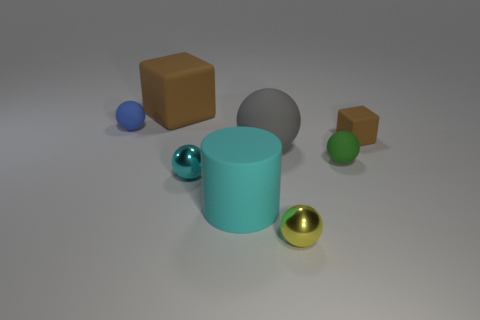Subtract 2 spheres. How many spheres are left? 3 Subtract all brown spheres. Subtract all brown cylinders. How many spheres are left? 5 Add 1 tiny cyan objects. How many objects exist? 9 Subtract all blocks. How many objects are left? 6 Add 8 matte cylinders. How many matte cylinders are left? 9 Add 6 cyan metallic objects. How many cyan metallic objects exist? 7 Subtract 0 blue cylinders. How many objects are left? 8 Subtract all rubber cylinders. Subtract all tiny green shiny balls. How many objects are left? 7 